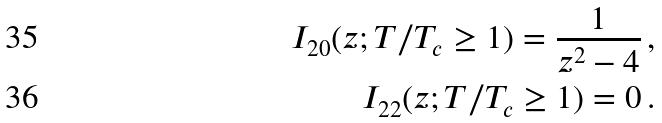Convert formula to latex. <formula><loc_0><loc_0><loc_500><loc_500>I _ { 2 0 } ( z ; T / T _ { c } \geq 1 ) = \frac { 1 } { z ^ { 2 } - 4 } \, , \\ I _ { 2 2 } ( z ; T / T _ { c } \geq 1 ) = 0 \, .</formula> 